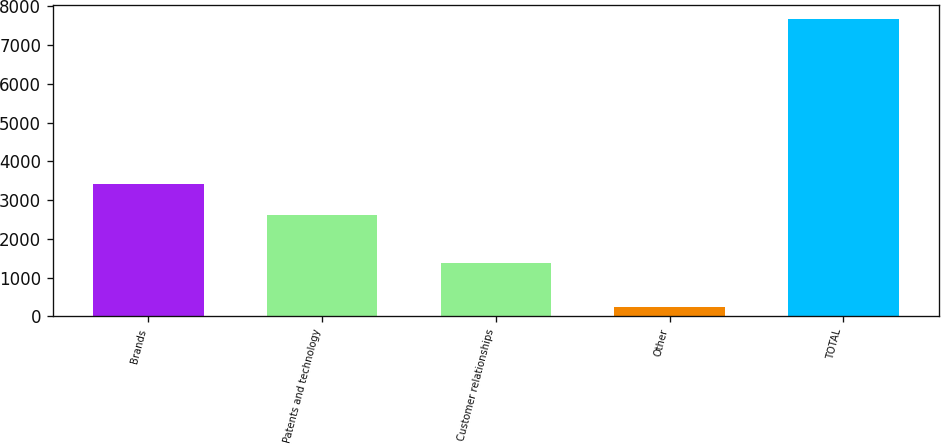<chart> <loc_0><loc_0><loc_500><loc_500><bar_chart><fcel>Brands<fcel>Patents and technology<fcel>Customer relationships<fcel>Other<fcel>TOTAL<nl><fcel>3409<fcel>2624<fcel>1382<fcel>246<fcel>7661<nl></chart> 